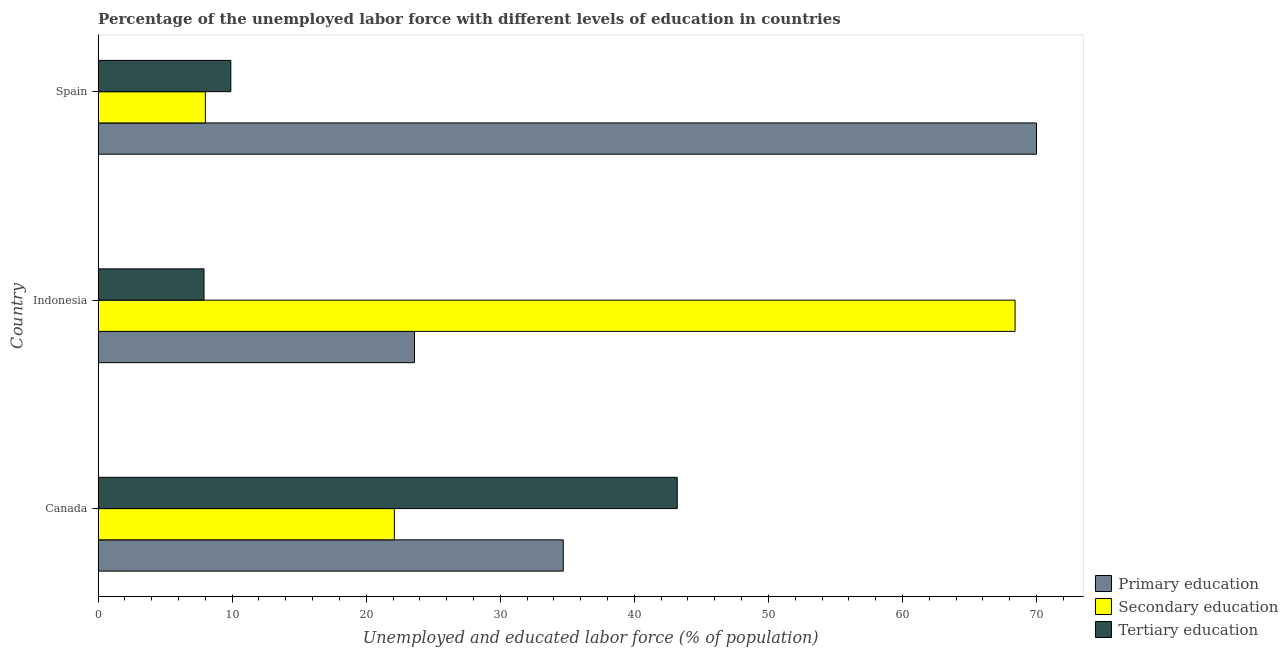How many groups of bars are there?
Your answer should be very brief. 3. Are the number of bars per tick equal to the number of legend labels?
Your answer should be compact. Yes. Are the number of bars on each tick of the Y-axis equal?
Keep it short and to the point. Yes. How many bars are there on the 3rd tick from the top?
Provide a short and direct response. 3. How many bars are there on the 3rd tick from the bottom?
Keep it short and to the point. 3. In how many cases, is the number of bars for a given country not equal to the number of legend labels?
Provide a succinct answer. 0. What is the percentage of labor force who received secondary education in Canada?
Offer a very short reply. 22.1. Across all countries, what is the maximum percentage of labor force who received tertiary education?
Give a very brief answer. 43.2. Across all countries, what is the minimum percentage of labor force who received secondary education?
Offer a very short reply. 8. In which country was the percentage of labor force who received secondary education minimum?
Provide a short and direct response. Spain. What is the total percentage of labor force who received primary education in the graph?
Give a very brief answer. 128.3. What is the difference between the percentage of labor force who received tertiary education in Canada and that in Indonesia?
Provide a short and direct response. 35.3. What is the difference between the percentage of labor force who received primary education in Indonesia and the percentage of labor force who received secondary education in Spain?
Offer a terse response. 15.6. What is the average percentage of labor force who received tertiary education per country?
Keep it short and to the point. 20.33. What is the ratio of the percentage of labor force who received secondary education in Canada to that in Indonesia?
Ensure brevity in your answer.  0.32. What is the difference between the highest and the second highest percentage of labor force who received tertiary education?
Ensure brevity in your answer.  33.3. What is the difference between the highest and the lowest percentage of labor force who received tertiary education?
Your answer should be compact. 35.3. In how many countries, is the percentage of labor force who received secondary education greater than the average percentage of labor force who received secondary education taken over all countries?
Offer a terse response. 1. What does the 2nd bar from the bottom in Indonesia represents?
Give a very brief answer. Secondary education. How many bars are there?
Your response must be concise. 9. What is the difference between two consecutive major ticks on the X-axis?
Provide a short and direct response. 10. Are the values on the major ticks of X-axis written in scientific E-notation?
Make the answer very short. No. Does the graph contain any zero values?
Ensure brevity in your answer.  No. Does the graph contain grids?
Your answer should be compact. No. Where does the legend appear in the graph?
Ensure brevity in your answer.  Bottom right. What is the title of the graph?
Offer a very short reply. Percentage of the unemployed labor force with different levels of education in countries. Does "Oil sources" appear as one of the legend labels in the graph?
Keep it short and to the point. No. What is the label or title of the X-axis?
Offer a very short reply. Unemployed and educated labor force (% of population). What is the Unemployed and educated labor force (% of population) in Primary education in Canada?
Ensure brevity in your answer.  34.7. What is the Unemployed and educated labor force (% of population) in Secondary education in Canada?
Make the answer very short. 22.1. What is the Unemployed and educated labor force (% of population) in Tertiary education in Canada?
Provide a succinct answer. 43.2. What is the Unemployed and educated labor force (% of population) of Primary education in Indonesia?
Give a very brief answer. 23.6. What is the Unemployed and educated labor force (% of population) in Secondary education in Indonesia?
Give a very brief answer. 68.4. What is the Unemployed and educated labor force (% of population) of Tertiary education in Indonesia?
Provide a succinct answer. 7.9. What is the Unemployed and educated labor force (% of population) in Primary education in Spain?
Your response must be concise. 70. What is the Unemployed and educated labor force (% of population) of Tertiary education in Spain?
Ensure brevity in your answer.  9.9. Across all countries, what is the maximum Unemployed and educated labor force (% of population) of Secondary education?
Offer a terse response. 68.4. Across all countries, what is the maximum Unemployed and educated labor force (% of population) of Tertiary education?
Your response must be concise. 43.2. Across all countries, what is the minimum Unemployed and educated labor force (% of population) of Primary education?
Provide a succinct answer. 23.6. Across all countries, what is the minimum Unemployed and educated labor force (% of population) in Secondary education?
Your response must be concise. 8. Across all countries, what is the minimum Unemployed and educated labor force (% of population) in Tertiary education?
Your answer should be compact. 7.9. What is the total Unemployed and educated labor force (% of population) of Primary education in the graph?
Keep it short and to the point. 128.3. What is the total Unemployed and educated labor force (% of population) of Secondary education in the graph?
Provide a succinct answer. 98.5. What is the total Unemployed and educated labor force (% of population) in Tertiary education in the graph?
Give a very brief answer. 61. What is the difference between the Unemployed and educated labor force (% of population) in Secondary education in Canada and that in Indonesia?
Your answer should be compact. -46.3. What is the difference between the Unemployed and educated labor force (% of population) of Tertiary education in Canada and that in Indonesia?
Your response must be concise. 35.3. What is the difference between the Unemployed and educated labor force (% of population) of Primary education in Canada and that in Spain?
Your answer should be very brief. -35.3. What is the difference between the Unemployed and educated labor force (% of population) of Secondary education in Canada and that in Spain?
Your response must be concise. 14.1. What is the difference between the Unemployed and educated labor force (% of population) in Tertiary education in Canada and that in Spain?
Give a very brief answer. 33.3. What is the difference between the Unemployed and educated labor force (% of population) of Primary education in Indonesia and that in Spain?
Your answer should be compact. -46.4. What is the difference between the Unemployed and educated labor force (% of population) of Secondary education in Indonesia and that in Spain?
Provide a short and direct response. 60.4. What is the difference between the Unemployed and educated labor force (% of population) in Primary education in Canada and the Unemployed and educated labor force (% of population) in Secondary education in Indonesia?
Provide a short and direct response. -33.7. What is the difference between the Unemployed and educated labor force (% of population) in Primary education in Canada and the Unemployed and educated labor force (% of population) in Tertiary education in Indonesia?
Provide a short and direct response. 26.8. What is the difference between the Unemployed and educated labor force (% of population) in Primary education in Canada and the Unemployed and educated labor force (% of population) in Secondary education in Spain?
Your answer should be very brief. 26.7. What is the difference between the Unemployed and educated labor force (% of population) of Primary education in Canada and the Unemployed and educated labor force (% of population) of Tertiary education in Spain?
Provide a succinct answer. 24.8. What is the difference between the Unemployed and educated labor force (% of population) in Secondary education in Canada and the Unemployed and educated labor force (% of population) in Tertiary education in Spain?
Provide a succinct answer. 12.2. What is the difference between the Unemployed and educated labor force (% of population) of Primary education in Indonesia and the Unemployed and educated labor force (% of population) of Secondary education in Spain?
Offer a very short reply. 15.6. What is the difference between the Unemployed and educated labor force (% of population) of Primary education in Indonesia and the Unemployed and educated labor force (% of population) of Tertiary education in Spain?
Your answer should be compact. 13.7. What is the difference between the Unemployed and educated labor force (% of population) of Secondary education in Indonesia and the Unemployed and educated labor force (% of population) of Tertiary education in Spain?
Ensure brevity in your answer.  58.5. What is the average Unemployed and educated labor force (% of population) of Primary education per country?
Keep it short and to the point. 42.77. What is the average Unemployed and educated labor force (% of population) of Secondary education per country?
Provide a succinct answer. 32.83. What is the average Unemployed and educated labor force (% of population) of Tertiary education per country?
Offer a terse response. 20.33. What is the difference between the Unemployed and educated labor force (% of population) in Secondary education and Unemployed and educated labor force (% of population) in Tertiary education in Canada?
Provide a succinct answer. -21.1. What is the difference between the Unemployed and educated labor force (% of population) in Primary education and Unemployed and educated labor force (% of population) in Secondary education in Indonesia?
Your answer should be compact. -44.8. What is the difference between the Unemployed and educated labor force (% of population) in Secondary education and Unemployed and educated labor force (% of population) in Tertiary education in Indonesia?
Provide a succinct answer. 60.5. What is the difference between the Unemployed and educated labor force (% of population) of Primary education and Unemployed and educated labor force (% of population) of Tertiary education in Spain?
Offer a very short reply. 60.1. What is the difference between the Unemployed and educated labor force (% of population) in Secondary education and Unemployed and educated labor force (% of population) in Tertiary education in Spain?
Your answer should be very brief. -1.9. What is the ratio of the Unemployed and educated labor force (% of population) in Primary education in Canada to that in Indonesia?
Keep it short and to the point. 1.47. What is the ratio of the Unemployed and educated labor force (% of population) of Secondary education in Canada to that in Indonesia?
Your answer should be compact. 0.32. What is the ratio of the Unemployed and educated labor force (% of population) of Tertiary education in Canada to that in Indonesia?
Give a very brief answer. 5.47. What is the ratio of the Unemployed and educated labor force (% of population) of Primary education in Canada to that in Spain?
Provide a succinct answer. 0.5. What is the ratio of the Unemployed and educated labor force (% of population) in Secondary education in Canada to that in Spain?
Your response must be concise. 2.76. What is the ratio of the Unemployed and educated labor force (% of population) in Tertiary education in Canada to that in Spain?
Provide a succinct answer. 4.36. What is the ratio of the Unemployed and educated labor force (% of population) of Primary education in Indonesia to that in Spain?
Make the answer very short. 0.34. What is the ratio of the Unemployed and educated labor force (% of population) in Secondary education in Indonesia to that in Spain?
Offer a terse response. 8.55. What is the ratio of the Unemployed and educated labor force (% of population) in Tertiary education in Indonesia to that in Spain?
Make the answer very short. 0.8. What is the difference between the highest and the second highest Unemployed and educated labor force (% of population) in Primary education?
Provide a short and direct response. 35.3. What is the difference between the highest and the second highest Unemployed and educated labor force (% of population) in Secondary education?
Your response must be concise. 46.3. What is the difference between the highest and the second highest Unemployed and educated labor force (% of population) of Tertiary education?
Offer a terse response. 33.3. What is the difference between the highest and the lowest Unemployed and educated labor force (% of population) in Primary education?
Give a very brief answer. 46.4. What is the difference between the highest and the lowest Unemployed and educated labor force (% of population) in Secondary education?
Your answer should be compact. 60.4. What is the difference between the highest and the lowest Unemployed and educated labor force (% of population) in Tertiary education?
Your answer should be compact. 35.3. 